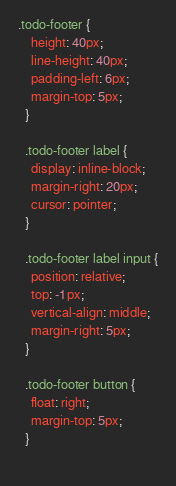<code> <loc_0><loc_0><loc_500><loc_500><_CSS_>.todo-footer {
    height: 40px;
    line-height: 40px;
    padding-left: 6px;
    margin-top: 5px;
  }
  
  .todo-footer label {
    display: inline-block;
    margin-right: 20px;
    cursor: pointer;
  }
  
  .todo-footer label input {
    position: relative;
    top: -1px;
    vertical-align: middle;
    margin-right: 5px;
  }
  
  .todo-footer button {
    float: right;
    margin-top: 5px;
  }
  </code> 